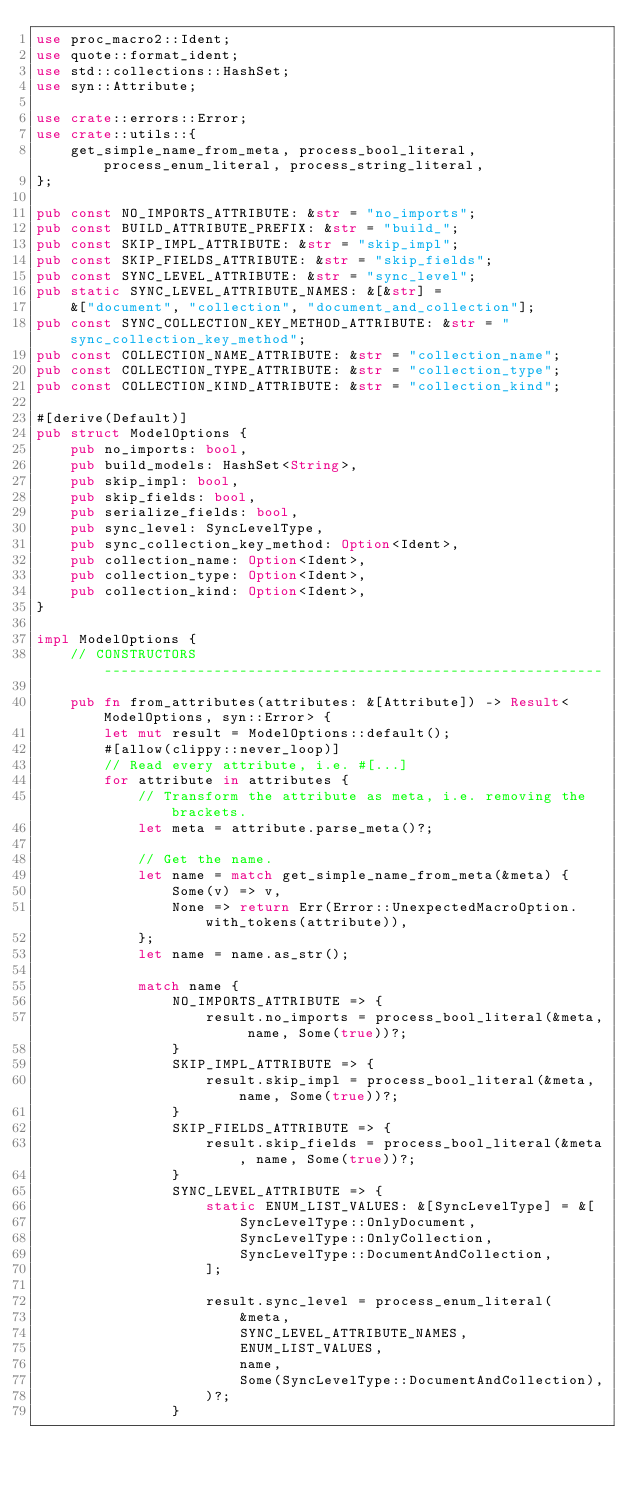Convert code to text. <code><loc_0><loc_0><loc_500><loc_500><_Rust_>use proc_macro2::Ident;
use quote::format_ident;
use std::collections::HashSet;
use syn::Attribute;

use crate::errors::Error;
use crate::utils::{
    get_simple_name_from_meta, process_bool_literal, process_enum_literal, process_string_literal,
};

pub const NO_IMPORTS_ATTRIBUTE: &str = "no_imports";
pub const BUILD_ATTRIBUTE_PREFIX: &str = "build_";
pub const SKIP_IMPL_ATTRIBUTE: &str = "skip_impl";
pub const SKIP_FIELDS_ATTRIBUTE: &str = "skip_fields";
pub const SYNC_LEVEL_ATTRIBUTE: &str = "sync_level";
pub static SYNC_LEVEL_ATTRIBUTE_NAMES: &[&str] =
    &["document", "collection", "document_and_collection"];
pub const SYNC_COLLECTION_KEY_METHOD_ATTRIBUTE: &str = "sync_collection_key_method";
pub const COLLECTION_NAME_ATTRIBUTE: &str = "collection_name";
pub const COLLECTION_TYPE_ATTRIBUTE: &str = "collection_type";
pub const COLLECTION_KIND_ATTRIBUTE: &str = "collection_kind";

#[derive(Default)]
pub struct ModelOptions {
    pub no_imports: bool,
    pub build_models: HashSet<String>,
    pub skip_impl: bool,
    pub skip_fields: bool,
    pub serialize_fields: bool,
    pub sync_level: SyncLevelType,
    pub sync_collection_key_method: Option<Ident>,
    pub collection_name: Option<Ident>,
    pub collection_type: Option<Ident>,
    pub collection_kind: Option<Ident>,
}

impl ModelOptions {
    // CONSTRUCTORS -----------------------------------------------------------

    pub fn from_attributes(attributes: &[Attribute]) -> Result<ModelOptions, syn::Error> {
        let mut result = ModelOptions::default();
        #[allow(clippy::never_loop)]
        // Read every attribute, i.e. #[...]
        for attribute in attributes {
            // Transform the attribute as meta, i.e. removing the brackets.
            let meta = attribute.parse_meta()?;

            // Get the name.
            let name = match get_simple_name_from_meta(&meta) {
                Some(v) => v,
                None => return Err(Error::UnexpectedMacroOption.with_tokens(attribute)),
            };
            let name = name.as_str();

            match name {
                NO_IMPORTS_ATTRIBUTE => {
                    result.no_imports = process_bool_literal(&meta, name, Some(true))?;
                }
                SKIP_IMPL_ATTRIBUTE => {
                    result.skip_impl = process_bool_literal(&meta, name, Some(true))?;
                }
                SKIP_FIELDS_ATTRIBUTE => {
                    result.skip_fields = process_bool_literal(&meta, name, Some(true))?;
                }
                SYNC_LEVEL_ATTRIBUTE => {
                    static ENUM_LIST_VALUES: &[SyncLevelType] = &[
                        SyncLevelType::OnlyDocument,
                        SyncLevelType::OnlyCollection,
                        SyncLevelType::DocumentAndCollection,
                    ];

                    result.sync_level = process_enum_literal(
                        &meta,
                        SYNC_LEVEL_ATTRIBUTE_NAMES,
                        ENUM_LIST_VALUES,
                        name,
                        Some(SyncLevelType::DocumentAndCollection),
                    )?;
                }</code> 